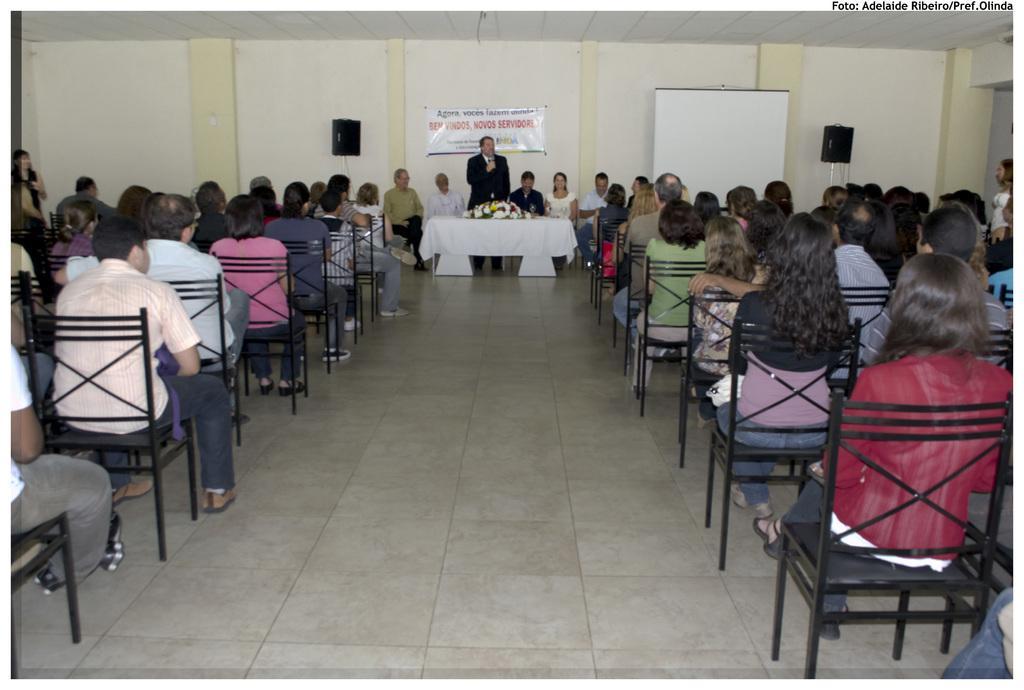In one or two sentences, can you explain what this image depicts? There are many persons sitting on chairs on the two sides of the room. In the background there is wall with a banner. There are two speakers and a board. There are some persons sitting in the background. A person in a black dress is holding a mic and standing. in front of him there is a table with a white cloth and a bouquet. 